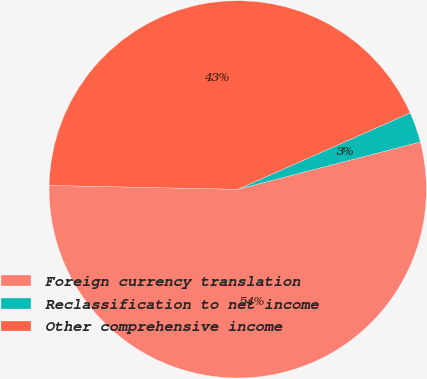Convert chart. <chart><loc_0><loc_0><loc_500><loc_500><pie_chart><fcel>Foreign currency translation<fcel>Reclassification to net income<fcel>Other comprehensive income<nl><fcel>54.37%<fcel>2.6%<fcel>43.03%<nl></chart> 